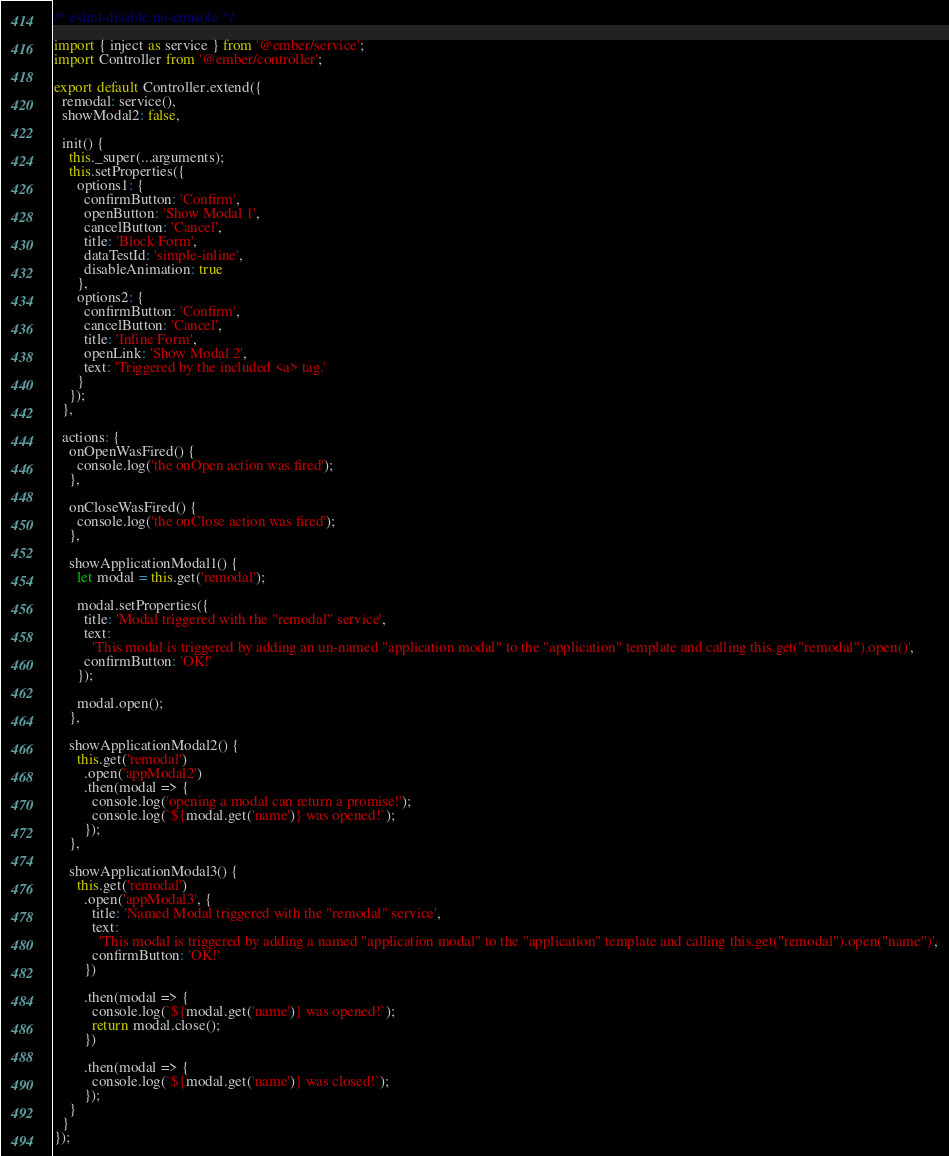Convert code to text. <code><loc_0><loc_0><loc_500><loc_500><_JavaScript_>/* eslint-disable no-console */

import { inject as service } from '@ember/service';
import Controller from '@ember/controller';

export default Controller.extend({
  remodal: service(),
  showModal2: false,

  init() {
    this._super(...arguments);
    this.setProperties({
      options1: {
        confirmButton: 'Confirm',
        openButton: 'Show Modal 1',
        cancelButton: 'Cancel',
        title: 'Block Form',
        dataTestId: 'simple-inline',
        disableAnimation: true
      },
      options2: {
        confirmButton: 'Confirm',
        cancelButton: 'Cancel',
        title: 'Inline Form',
        openLink: 'Show Modal 2',
        text: 'Triggered by the included <a> tag.'
      }
    });
  },

  actions: {
    onOpenWasFired() {
      console.log('the onOpen action was fired');
    },

    onCloseWasFired() {
      console.log('the onClose action was fired');
    },

    showApplicationModal1() {
      let modal = this.get('remodal');

      modal.setProperties({
        title: 'Modal triggered with the "remodal" service',
        text:
          'This modal is triggered by adding an un-named "application modal" to the "application" template and calling this.get("remodal").open()',
        confirmButton: 'OK!'
      });

      modal.open();
    },

    showApplicationModal2() {
      this.get('remodal')
        .open('appModal2')
        .then(modal => {
          console.log('opening a modal can return a promise!');
          console.log(`${modal.get('name')} was opened!`);
        });
    },

    showApplicationModal3() {
      this.get('remodal')
        .open('appModal3', {
          title: 'Named Modal triggered with the "remodal" service',
          text:
            'This modal is triggered by adding a named "application modal" to the "application" template and calling this.get("remodal").open("name")',
          confirmButton: 'OK!'
        })

        .then(modal => {
          console.log(`${modal.get('name')} was opened!`);
          return modal.close();
        })

        .then(modal => {
          console.log(`${modal.get('name')} was closed!`);
        });
    }
  }
});
</code> 